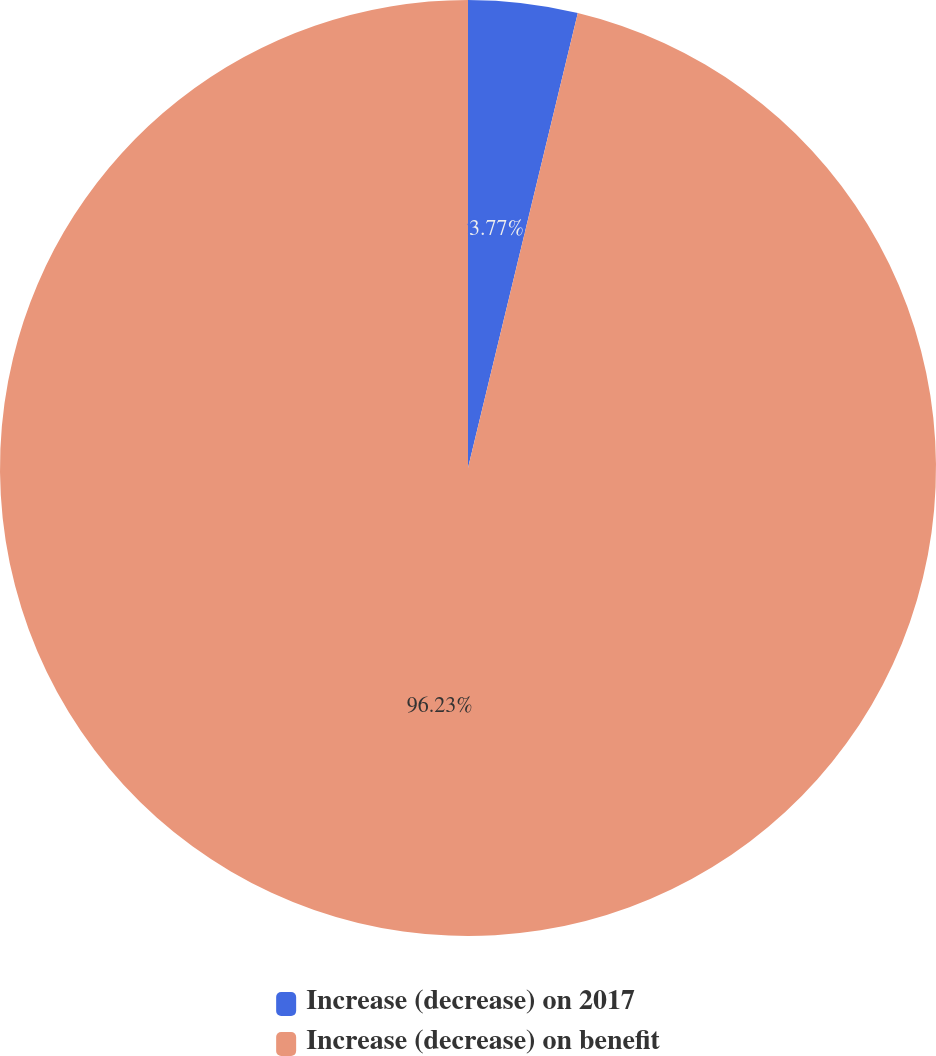Convert chart to OTSL. <chart><loc_0><loc_0><loc_500><loc_500><pie_chart><fcel>Increase (decrease) on 2017<fcel>Increase (decrease) on benefit<nl><fcel>3.77%<fcel>96.23%<nl></chart> 